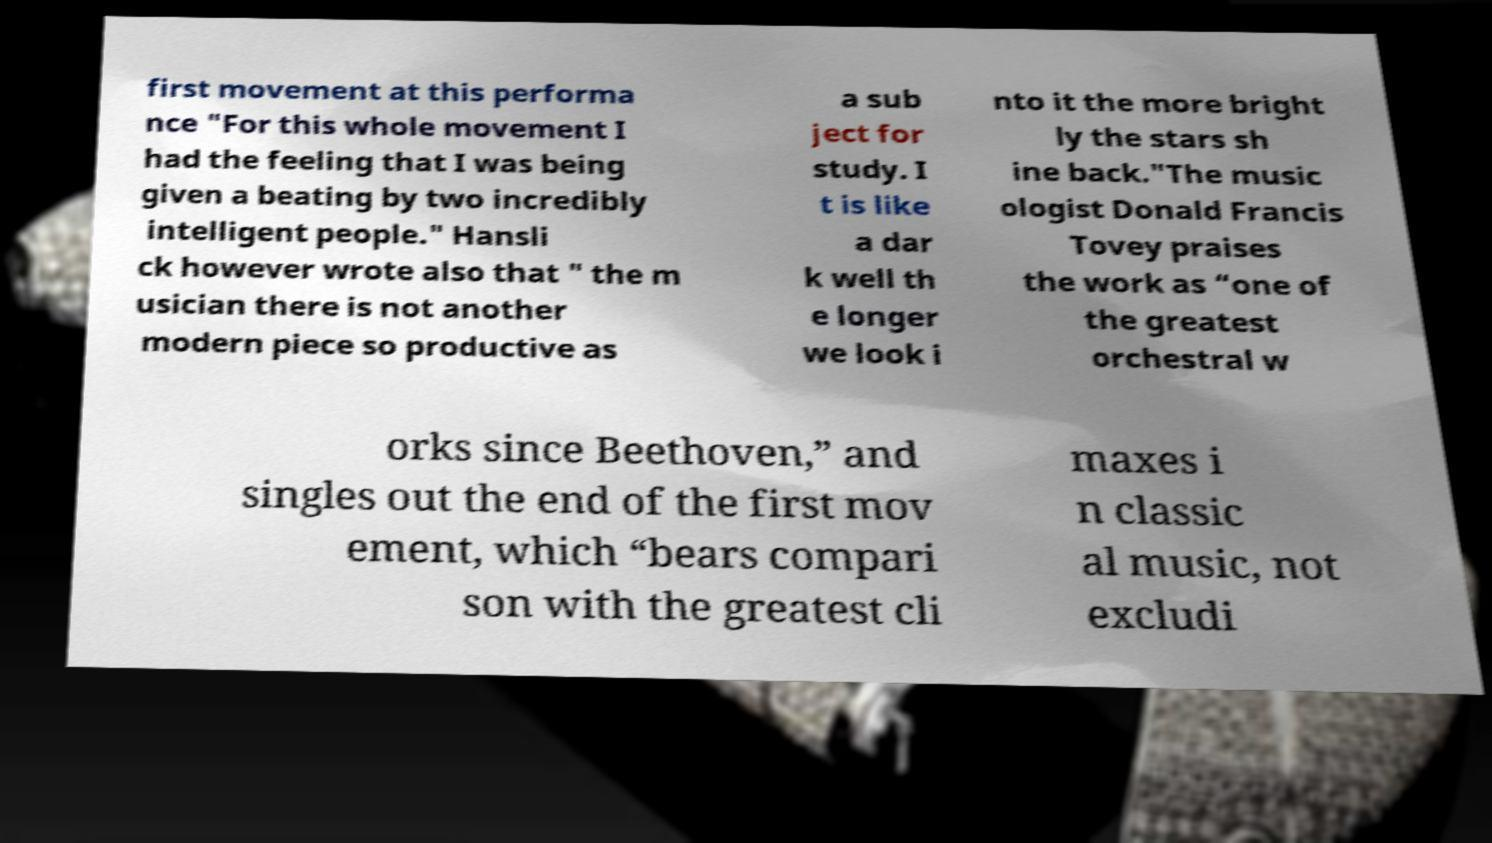Could you extract and type out the text from this image? first movement at this performa nce "For this whole movement I had the feeling that I was being given a beating by two incredibly intelligent people." Hansli ck however wrote also that " the m usician there is not another modern piece so productive as a sub ject for study. I t is like a dar k well th e longer we look i nto it the more bright ly the stars sh ine back."The music ologist Donald Francis Tovey praises the work as “one of the greatest orchestral w orks since Beethoven,” and singles out the end of the first mov ement, which “bears compari son with the greatest cli maxes i n classic al music, not excludi 